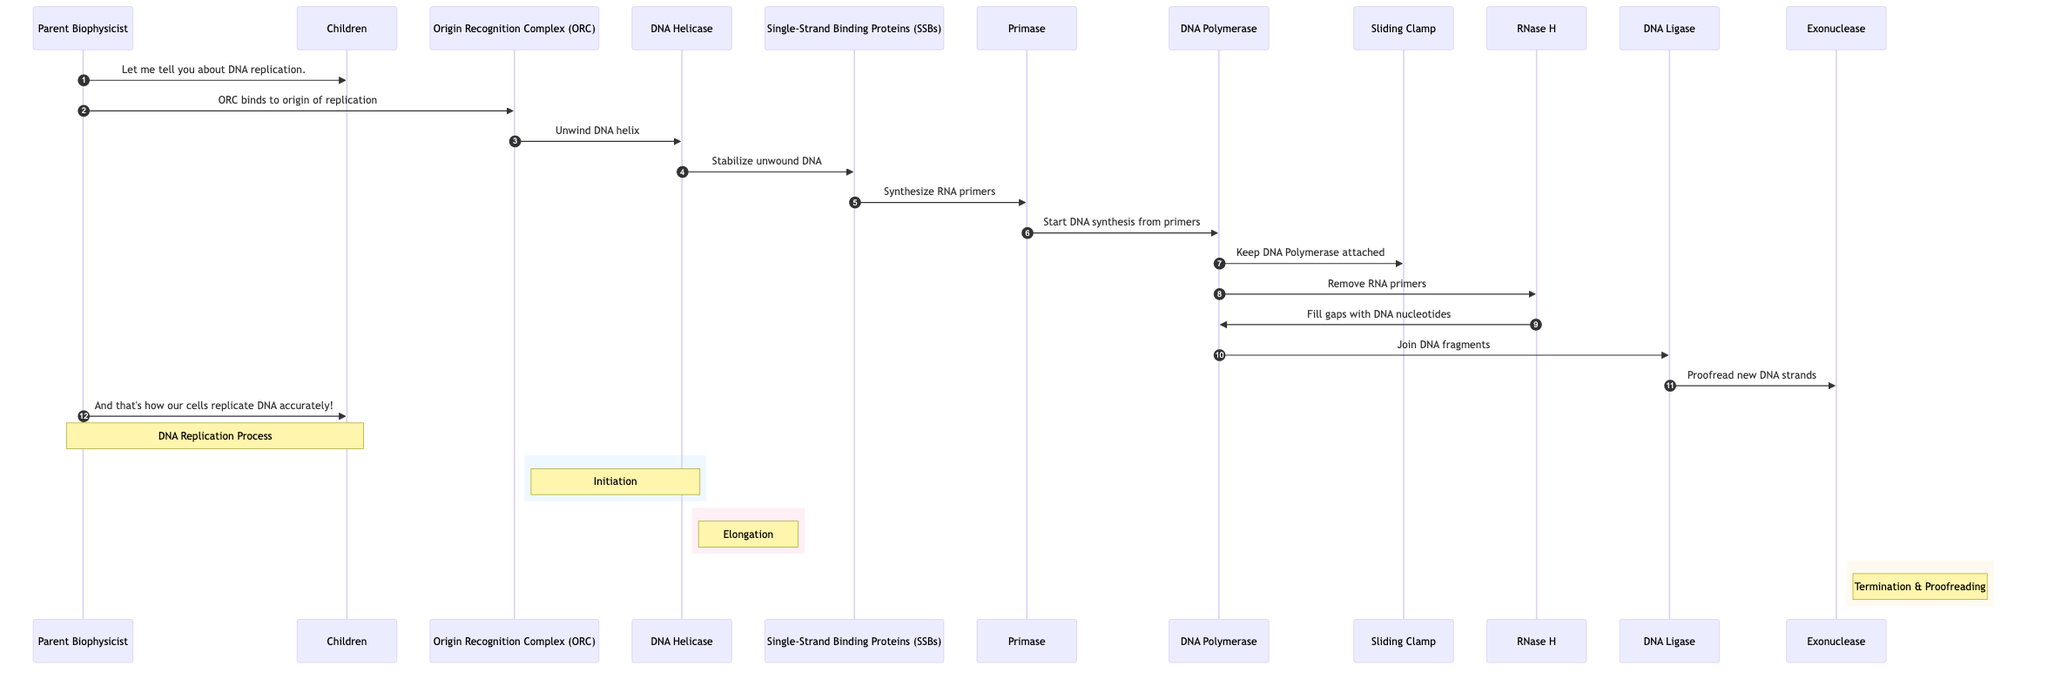What is the first complex involved in DNA replication? The first complex shown in the diagram is the Origin Recognition Complex (ORC), which initiates DNA replication by binding to the origin of replication.
Answer: Origin Recognition Complex (ORC) How many enzymes are involved in the DNA replication process as depicted in the diagram? The diagram includes four enzymes: DNA Helicase, Primase, RNase H, and DNA Ligase, totaling four enzymes involved in the replication process.
Answer: 4 What role does DNA Helicase play in the process? DNA Helicase unwinds the DNA helix, which is an important step in preparing the DNA for replication.
Answer: Unwinds DNA helix Which proteins stabilize the unwound DNA during replication? The Single-Strand Binding Proteins (SSBs) bind to the unwound DNA to stabilize it and prevent it from re-annealing.
Answer: Single-Strand Binding Proteins (SSBs) Who synthesizes RNA primers for DNA replication? The Primase synthesizes RNA primers, which are necessary for DNA Polymerase to begin synthesizing new DNA strands.
Answer: Primase What happens after DNA Polymerase elongates the DNA strands? After elongation, RNase H is responsible for removing RNA primers that were used to initiate the synthesis of new DNA strands.
Answer: RNase H removes RNA primers During which phase does the Exonuclease proofread the DNA? The Exonuclease proofs the new DNA strands during the Termination phase, ensuring that any errors are corrected before the process is complete.
Answer: Termination What keeps DNA Polymerase attached to the DNA strand? The Sliding Clamp protein is responsible for keeping DNA Polymerase attached to the DNA strand throughout the elongation process.
Answer: Sliding Clamp What is shown as the final step of the DNA replication process in the diagram? The final step in the DNA replication process depicted in the diagram is the action of the Exonuclease, which proofs the newly synthesized DNA strands for accuracy.
Answer: Exonuclease proofreads the new DNA strands 